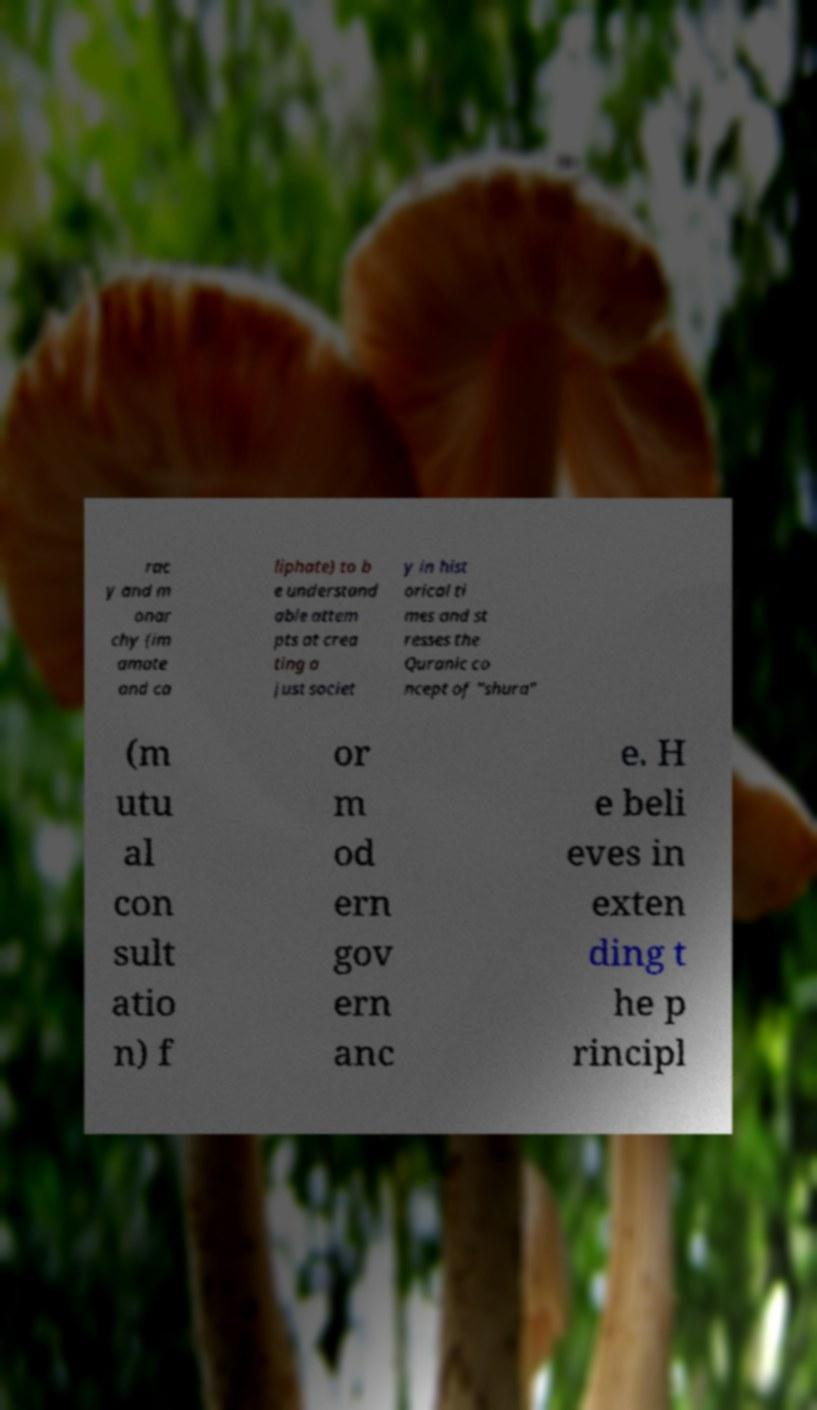For documentation purposes, I need the text within this image transcribed. Could you provide that? rac y and m onar chy (im amate and ca liphate) to b e understand able attem pts at crea ting a just societ y in hist orical ti mes and st resses the Quranic co ncept of "shura" (m utu al con sult atio n) f or m od ern gov ern anc e. H e beli eves in exten ding t he p rincipl 